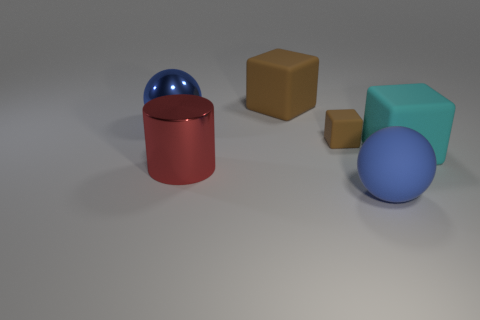What is the material of the large object that is the same color as the metal ball?
Give a very brief answer. Rubber. There is a big object that is in front of the large blue shiny thing and on the left side of the blue matte ball; what is its shape?
Your answer should be compact. Cylinder. There is a ball that is the same material as the big red thing; what color is it?
Your answer should be very brief. Blue. Are there an equal number of big cyan things behind the shiny ball and matte things?
Make the answer very short. No. What is the shape of the brown matte thing that is the same size as the cyan matte cube?
Provide a succinct answer. Cube. What number of other objects are the same shape as the blue rubber object?
Provide a short and direct response. 1. There is a red cylinder; is its size the same as the sphere that is left of the tiny rubber object?
Your answer should be very brief. Yes. How many things are either big blue spheres that are on the left side of the large brown rubber block or big cyan matte blocks?
Your answer should be very brief. 2. What shape is the metal object that is in front of the cyan matte thing?
Your answer should be very brief. Cylinder. Are there the same number of large cyan objects that are on the left side of the large cyan rubber object and large metal things that are behind the big brown object?
Give a very brief answer. Yes. 